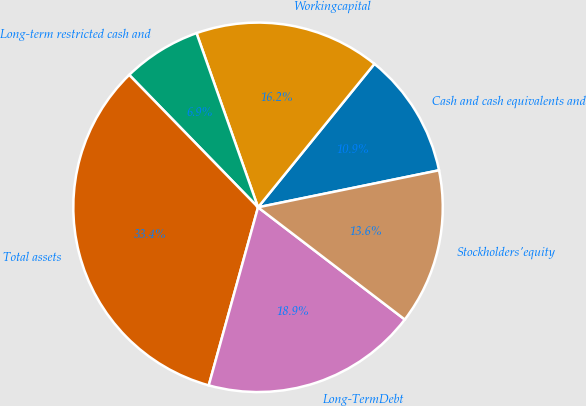Convert chart to OTSL. <chart><loc_0><loc_0><loc_500><loc_500><pie_chart><fcel>Cash and cash equivalents and<fcel>Workingcapital<fcel>Long-term restricted cash and<fcel>Total assets<fcel>Long-TermDebt<fcel>Stockholders'equity<nl><fcel>10.94%<fcel>16.25%<fcel>6.88%<fcel>33.42%<fcel>18.91%<fcel>13.6%<nl></chart> 